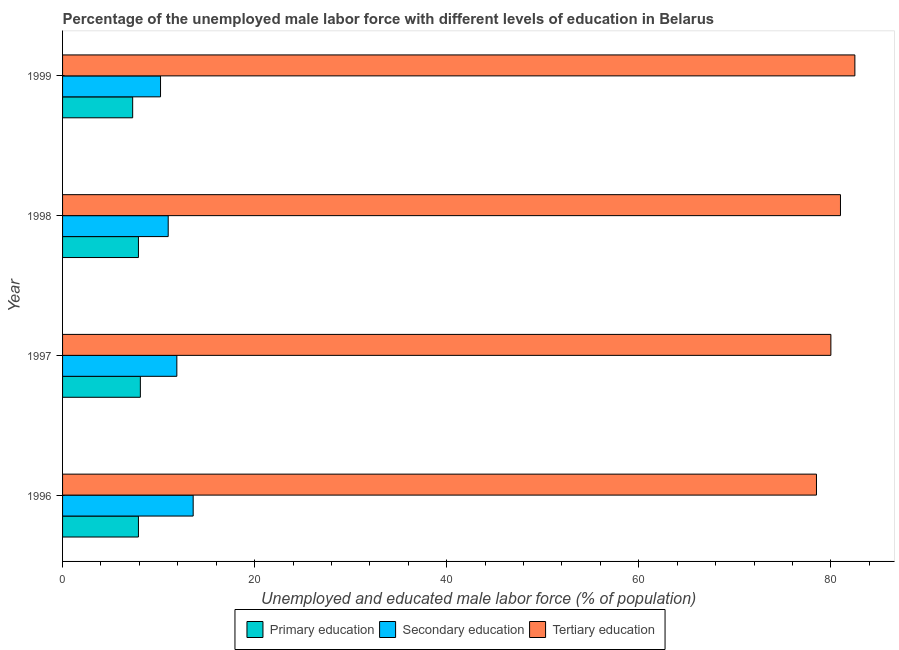How many different coloured bars are there?
Provide a succinct answer. 3. How many groups of bars are there?
Your response must be concise. 4. How many bars are there on the 2nd tick from the top?
Offer a terse response. 3. What is the label of the 4th group of bars from the top?
Ensure brevity in your answer.  1996. In how many cases, is the number of bars for a given year not equal to the number of legend labels?
Provide a succinct answer. 0. What is the percentage of male labor force who received primary education in 1998?
Your answer should be very brief. 7.9. Across all years, what is the maximum percentage of male labor force who received tertiary education?
Your response must be concise. 82.5. Across all years, what is the minimum percentage of male labor force who received secondary education?
Provide a succinct answer. 10.2. In which year was the percentage of male labor force who received primary education maximum?
Keep it short and to the point. 1997. What is the total percentage of male labor force who received primary education in the graph?
Your answer should be compact. 31.2. What is the difference between the percentage of male labor force who received primary education in 1996 and that in 1999?
Give a very brief answer. 0.6. What is the difference between the percentage of male labor force who received secondary education in 1998 and the percentage of male labor force who received tertiary education in 1996?
Make the answer very short. -67.5. What is the average percentage of male labor force who received secondary education per year?
Provide a succinct answer. 11.68. In the year 1999, what is the difference between the percentage of male labor force who received secondary education and percentage of male labor force who received primary education?
Give a very brief answer. 2.9. In how many years, is the percentage of male labor force who received secondary education greater than 80 %?
Your answer should be compact. 0. What is the ratio of the percentage of male labor force who received tertiary education in 1997 to that in 1999?
Ensure brevity in your answer.  0.97. Is the difference between the percentage of male labor force who received primary education in 1996 and 1999 greater than the difference between the percentage of male labor force who received tertiary education in 1996 and 1999?
Provide a succinct answer. Yes. What is the difference between the highest and the lowest percentage of male labor force who received primary education?
Provide a short and direct response. 0.8. Is the sum of the percentage of male labor force who received secondary education in 1996 and 1998 greater than the maximum percentage of male labor force who received tertiary education across all years?
Ensure brevity in your answer.  No. What does the 3rd bar from the top in 1996 represents?
Offer a terse response. Primary education. What does the 3rd bar from the bottom in 1998 represents?
Make the answer very short. Tertiary education. How many bars are there?
Your response must be concise. 12. What is the difference between two consecutive major ticks on the X-axis?
Give a very brief answer. 20. Where does the legend appear in the graph?
Offer a very short reply. Bottom center. What is the title of the graph?
Offer a terse response. Percentage of the unemployed male labor force with different levels of education in Belarus. Does "Fuel" appear as one of the legend labels in the graph?
Offer a terse response. No. What is the label or title of the X-axis?
Keep it short and to the point. Unemployed and educated male labor force (% of population). What is the label or title of the Y-axis?
Make the answer very short. Year. What is the Unemployed and educated male labor force (% of population) of Primary education in 1996?
Offer a very short reply. 7.9. What is the Unemployed and educated male labor force (% of population) of Secondary education in 1996?
Your answer should be very brief. 13.6. What is the Unemployed and educated male labor force (% of population) of Tertiary education in 1996?
Offer a very short reply. 78.5. What is the Unemployed and educated male labor force (% of population) in Primary education in 1997?
Provide a short and direct response. 8.1. What is the Unemployed and educated male labor force (% of population) of Secondary education in 1997?
Your answer should be very brief. 11.9. What is the Unemployed and educated male labor force (% of population) in Tertiary education in 1997?
Your answer should be compact. 80. What is the Unemployed and educated male labor force (% of population) of Primary education in 1998?
Ensure brevity in your answer.  7.9. What is the Unemployed and educated male labor force (% of population) in Secondary education in 1998?
Your answer should be compact. 11. What is the Unemployed and educated male labor force (% of population) of Primary education in 1999?
Your answer should be compact. 7.3. What is the Unemployed and educated male labor force (% of population) in Secondary education in 1999?
Provide a short and direct response. 10.2. What is the Unemployed and educated male labor force (% of population) in Tertiary education in 1999?
Your answer should be very brief. 82.5. Across all years, what is the maximum Unemployed and educated male labor force (% of population) of Primary education?
Ensure brevity in your answer.  8.1. Across all years, what is the maximum Unemployed and educated male labor force (% of population) of Secondary education?
Offer a very short reply. 13.6. Across all years, what is the maximum Unemployed and educated male labor force (% of population) in Tertiary education?
Ensure brevity in your answer.  82.5. Across all years, what is the minimum Unemployed and educated male labor force (% of population) in Primary education?
Offer a terse response. 7.3. Across all years, what is the minimum Unemployed and educated male labor force (% of population) of Secondary education?
Your response must be concise. 10.2. Across all years, what is the minimum Unemployed and educated male labor force (% of population) of Tertiary education?
Your answer should be compact. 78.5. What is the total Unemployed and educated male labor force (% of population) in Primary education in the graph?
Make the answer very short. 31.2. What is the total Unemployed and educated male labor force (% of population) of Secondary education in the graph?
Your answer should be compact. 46.7. What is the total Unemployed and educated male labor force (% of population) in Tertiary education in the graph?
Make the answer very short. 322. What is the difference between the Unemployed and educated male labor force (% of population) in Secondary education in 1996 and that in 1997?
Offer a terse response. 1.7. What is the difference between the Unemployed and educated male labor force (% of population) in Secondary education in 1996 and that in 1998?
Make the answer very short. 2.6. What is the difference between the Unemployed and educated male labor force (% of population) of Primary education in 1996 and that in 1999?
Offer a terse response. 0.6. What is the difference between the Unemployed and educated male labor force (% of population) of Secondary education in 1996 and that in 1999?
Keep it short and to the point. 3.4. What is the difference between the Unemployed and educated male labor force (% of population) in Secondary education in 1997 and that in 1998?
Your response must be concise. 0.9. What is the difference between the Unemployed and educated male labor force (% of population) of Tertiary education in 1997 and that in 1998?
Offer a terse response. -1. What is the difference between the Unemployed and educated male labor force (% of population) in Primary education in 1997 and that in 1999?
Offer a terse response. 0.8. What is the difference between the Unemployed and educated male labor force (% of population) of Secondary education in 1998 and that in 1999?
Your answer should be very brief. 0.8. What is the difference between the Unemployed and educated male labor force (% of population) in Primary education in 1996 and the Unemployed and educated male labor force (% of population) in Tertiary education in 1997?
Give a very brief answer. -72.1. What is the difference between the Unemployed and educated male labor force (% of population) of Secondary education in 1996 and the Unemployed and educated male labor force (% of population) of Tertiary education in 1997?
Offer a terse response. -66.4. What is the difference between the Unemployed and educated male labor force (% of population) in Primary education in 1996 and the Unemployed and educated male labor force (% of population) in Secondary education in 1998?
Your response must be concise. -3.1. What is the difference between the Unemployed and educated male labor force (% of population) of Primary education in 1996 and the Unemployed and educated male labor force (% of population) of Tertiary education in 1998?
Provide a short and direct response. -73.1. What is the difference between the Unemployed and educated male labor force (% of population) in Secondary education in 1996 and the Unemployed and educated male labor force (% of population) in Tertiary education in 1998?
Make the answer very short. -67.4. What is the difference between the Unemployed and educated male labor force (% of population) of Primary education in 1996 and the Unemployed and educated male labor force (% of population) of Secondary education in 1999?
Your response must be concise. -2.3. What is the difference between the Unemployed and educated male labor force (% of population) in Primary education in 1996 and the Unemployed and educated male labor force (% of population) in Tertiary education in 1999?
Offer a terse response. -74.6. What is the difference between the Unemployed and educated male labor force (% of population) in Secondary education in 1996 and the Unemployed and educated male labor force (% of population) in Tertiary education in 1999?
Provide a short and direct response. -68.9. What is the difference between the Unemployed and educated male labor force (% of population) in Primary education in 1997 and the Unemployed and educated male labor force (% of population) in Tertiary education in 1998?
Keep it short and to the point. -72.9. What is the difference between the Unemployed and educated male labor force (% of population) in Secondary education in 1997 and the Unemployed and educated male labor force (% of population) in Tertiary education in 1998?
Provide a succinct answer. -69.1. What is the difference between the Unemployed and educated male labor force (% of population) of Primary education in 1997 and the Unemployed and educated male labor force (% of population) of Secondary education in 1999?
Your answer should be compact. -2.1. What is the difference between the Unemployed and educated male labor force (% of population) of Primary education in 1997 and the Unemployed and educated male labor force (% of population) of Tertiary education in 1999?
Keep it short and to the point. -74.4. What is the difference between the Unemployed and educated male labor force (% of population) of Secondary education in 1997 and the Unemployed and educated male labor force (% of population) of Tertiary education in 1999?
Make the answer very short. -70.6. What is the difference between the Unemployed and educated male labor force (% of population) of Primary education in 1998 and the Unemployed and educated male labor force (% of population) of Tertiary education in 1999?
Keep it short and to the point. -74.6. What is the difference between the Unemployed and educated male labor force (% of population) of Secondary education in 1998 and the Unemployed and educated male labor force (% of population) of Tertiary education in 1999?
Offer a very short reply. -71.5. What is the average Unemployed and educated male labor force (% of population) in Primary education per year?
Provide a short and direct response. 7.8. What is the average Unemployed and educated male labor force (% of population) of Secondary education per year?
Make the answer very short. 11.68. What is the average Unemployed and educated male labor force (% of population) in Tertiary education per year?
Offer a terse response. 80.5. In the year 1996, what is the difference between the Unemployed and educated male labor force (% of population) of Primary education and Unemployed and educated male labor force (% of population) of Tertiary education?
Your answer should be compact. -70.6. In the year 1996, what is the difference between the Unemployed and educated male labor force (% of population) in Secondary education and Unemployed and educated male labor force (% of population) in Tertiary education?
Make the answer very short. -64.9. In the year 1997, what is the difference between the Unemployed and educated male labor force (% of population) in Primary education and Unemployed and educated male labor force (% of population) in Secondary education?
Offer a terse response. -3.8. In the year 1997, what is the difference between the Unemployed and educated male labor force (% of population) in Primary education and Unemployed and educated male labor force (% of population) in Tertiary education?
Provide a succinct answer. -71.9. In the year 1997, what is the difference between the Unemployed and educated male labor force (% of population) in Secondary education and Unemployed and educated male labor force (% of population) in Tertiary education?
Provide a short and direct response. -68.1. In the year 1998, what is the difference between the Unemployed and educated male labor force (% of population) in Primary education and Unemployed and educated male labor force (% of population) in Secondary education?
Your answer should be very brief. -3.1. In the year 1998, what is the difference between the Unemployed and educated male labor force (% of population) of Primary education and Unemployed and educated male labor force (% of population) of Tertiary education?
Your response must be concise. -73.1. In the year 1998, what is the difference between the Unemployed and educated male labor force (% of population) in Secondary education and Unemployed and educated male labor force (% of population) in Tertiary education?
Make the answer very short. -70. In the year 1999, what is the difference between the Unemployed and educated male labor force (% of population) of Primary education and Unemployed and educated male labor force (% of population) of Secondary education?
Ensure brevity in your answer.  -2.9. In the year 1999, what is the difference between the Unemployed and educated male labor force (% of population) in Primary education and Unemployed and educated male labor force (% of population) in Tertiary education?
Your answer should be compact. -75.2. In the year 1999, what is the difference between the Unemployed and educated male labor force (% of population) of Secondary education and Unemployed and educated male labor force (% of population) of Tertiary education?
Your response must be concise. -72.3. What is the ratio of the Unemployed and educated male labor force (% of population) in Primary education in 1996 to that in 1997?
Provide a short and direct response. 0.98. What is the ratio of the Unemployed and educated male labor force (% of population) of Secondary education in 1996 to that in 1997?
Your answer should be very brief. 1.14. What is the ratio of the Unemployed and educated male labor force (% of population) of Tertiary education in 1996 to that in 1997?
Offer a very short reply. 0.98. What is the ratio of the Unemployed and educated male labor force (% of population) in Primary education in 1996 to that in 1998?
Offer a very short reply. 1. What is the ratio of the Unemployed and educated male labor force (% of population) of Secondary education in 1996 to that in 1998?
Offer a terse response. 1.24. What is the ratio of the Unemployed and educated male labor force (% of population) of Tertiary education in 1996 to that in 1998?
Ensure brevity in your answer.  0.97. What is the ratio of the Unemployed and educated male labor force (% of population) in Primary education in 1996 to that in 1999?
Offer a terse response. 1.08. What is the ratio of the Unemployed and educated male labor force (% of population) of Tertiary education in 1996 to that in 1999?
Offer a terse response. 0.95. What is the ratio of the Unemployed and educated male labor force (% of population) of Primary education in 1997 to that in 1998?
Offer a terse response. 1.03. What is the ratio of the Unemployed and educated male labor force (% of population) of Secondary education in 1997 to that in 1998?
Give a very brief answer. 1.08. What is the ratio of the Unemployed and educated male labor force (% of population) in Primary education in 1997 to that in 1999?
Provide a short and direct response. 1.11. What is the ratio of the Unemployed and educated male labor force (% of population) in Secondary education in 1997 to that in 1999?
Provide a short and direct response. 1.17. What is the ratio of the Unemployed and educated male labor force (% of population) of Tertiary education in 1997 to that in 1999?
Your answer should be very brief. 0.97. What is the ratio of the Unemployed and educated male labor force (% of population) in Primary education in 1998 to that in 1999?
Keep it short and to the point. 1.08. What is the ratio of the Unemployed and educated male labor force (% of population) in Secondary education in 1998 to that in 1999?
Ensure brevity in your answer.  1.08. What is the ratio of the Unemployed and educated male labor force (% of population) in Tertiary education in 1998 to that in 1999?
Offer a very short reply. 0.98. What is the difference between the highest and the lowest Unemployed and educated male labor force (% of population) in Primary education?
Your answer should be very brief. 0.8. What is the difference between the highest and the lowest Unemployed and educated male labor force (% of population) of Secondary education?
Your answer should be very brief. 3.4. What is the difference between the highest and the lowest Unemployed and educated male labor force (% of population) in Tertiary education?
Your answer should be compact. 4. 